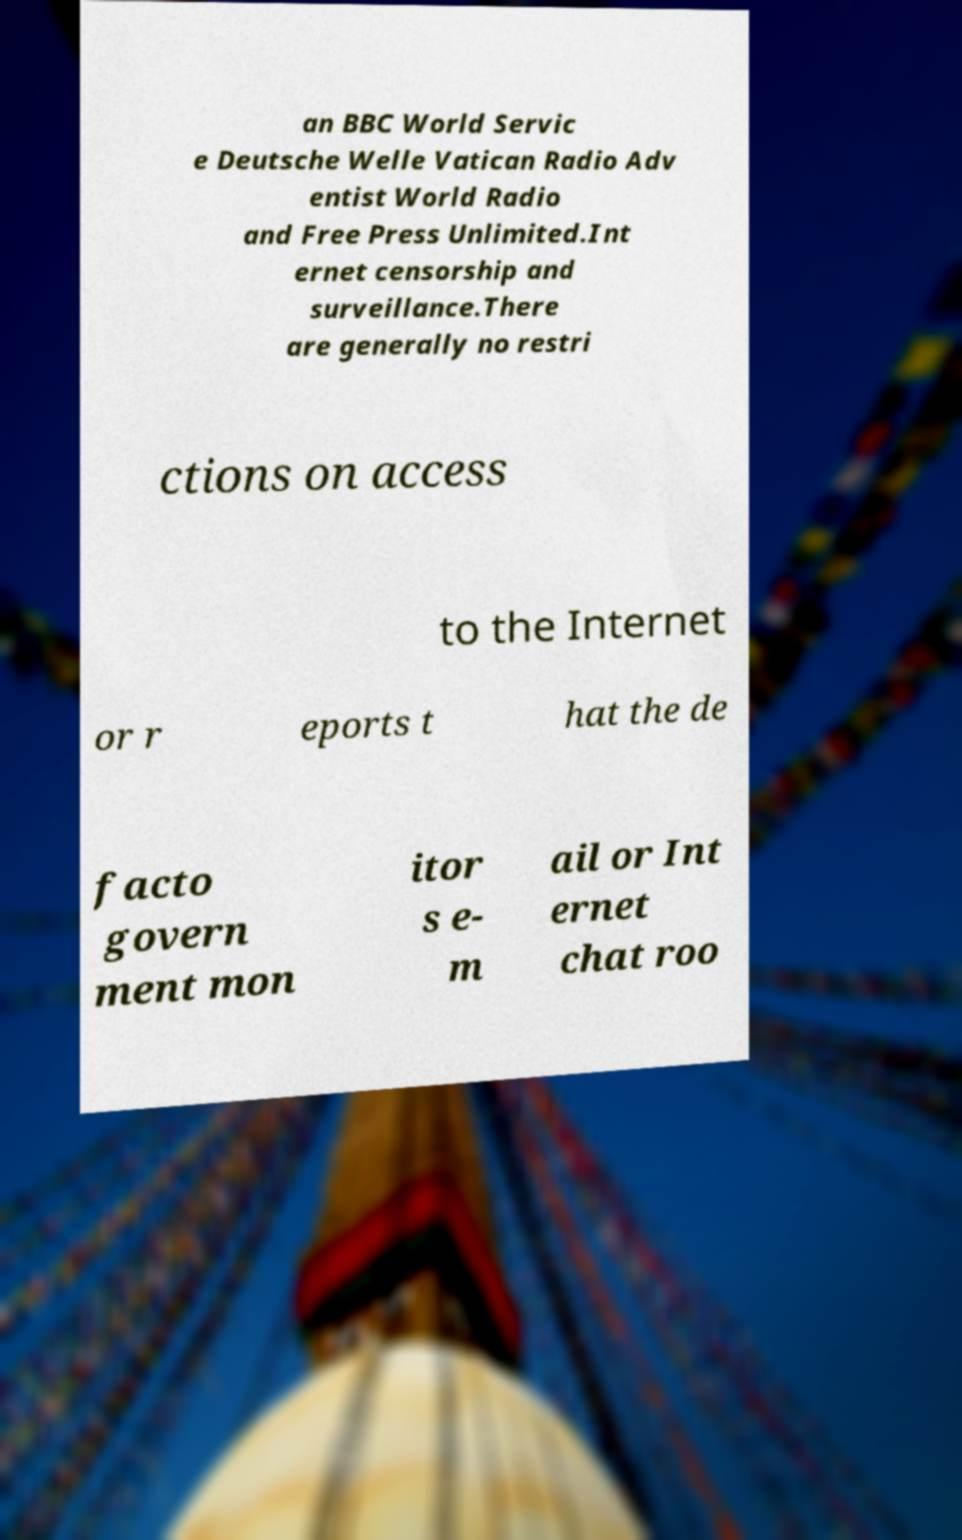I need the written content from this picture converted into text. Can you do that? an BBC World Servic e Deutsche Welle Vatican Radio Adv entist World Radio and Free Press Unlimited.Int ernet censorship and surveillance.There are generally no restri ctions on access to the Internet or r eports t hat the de facto govern ment mon itor s e- m ail or Int ernet chat roo 